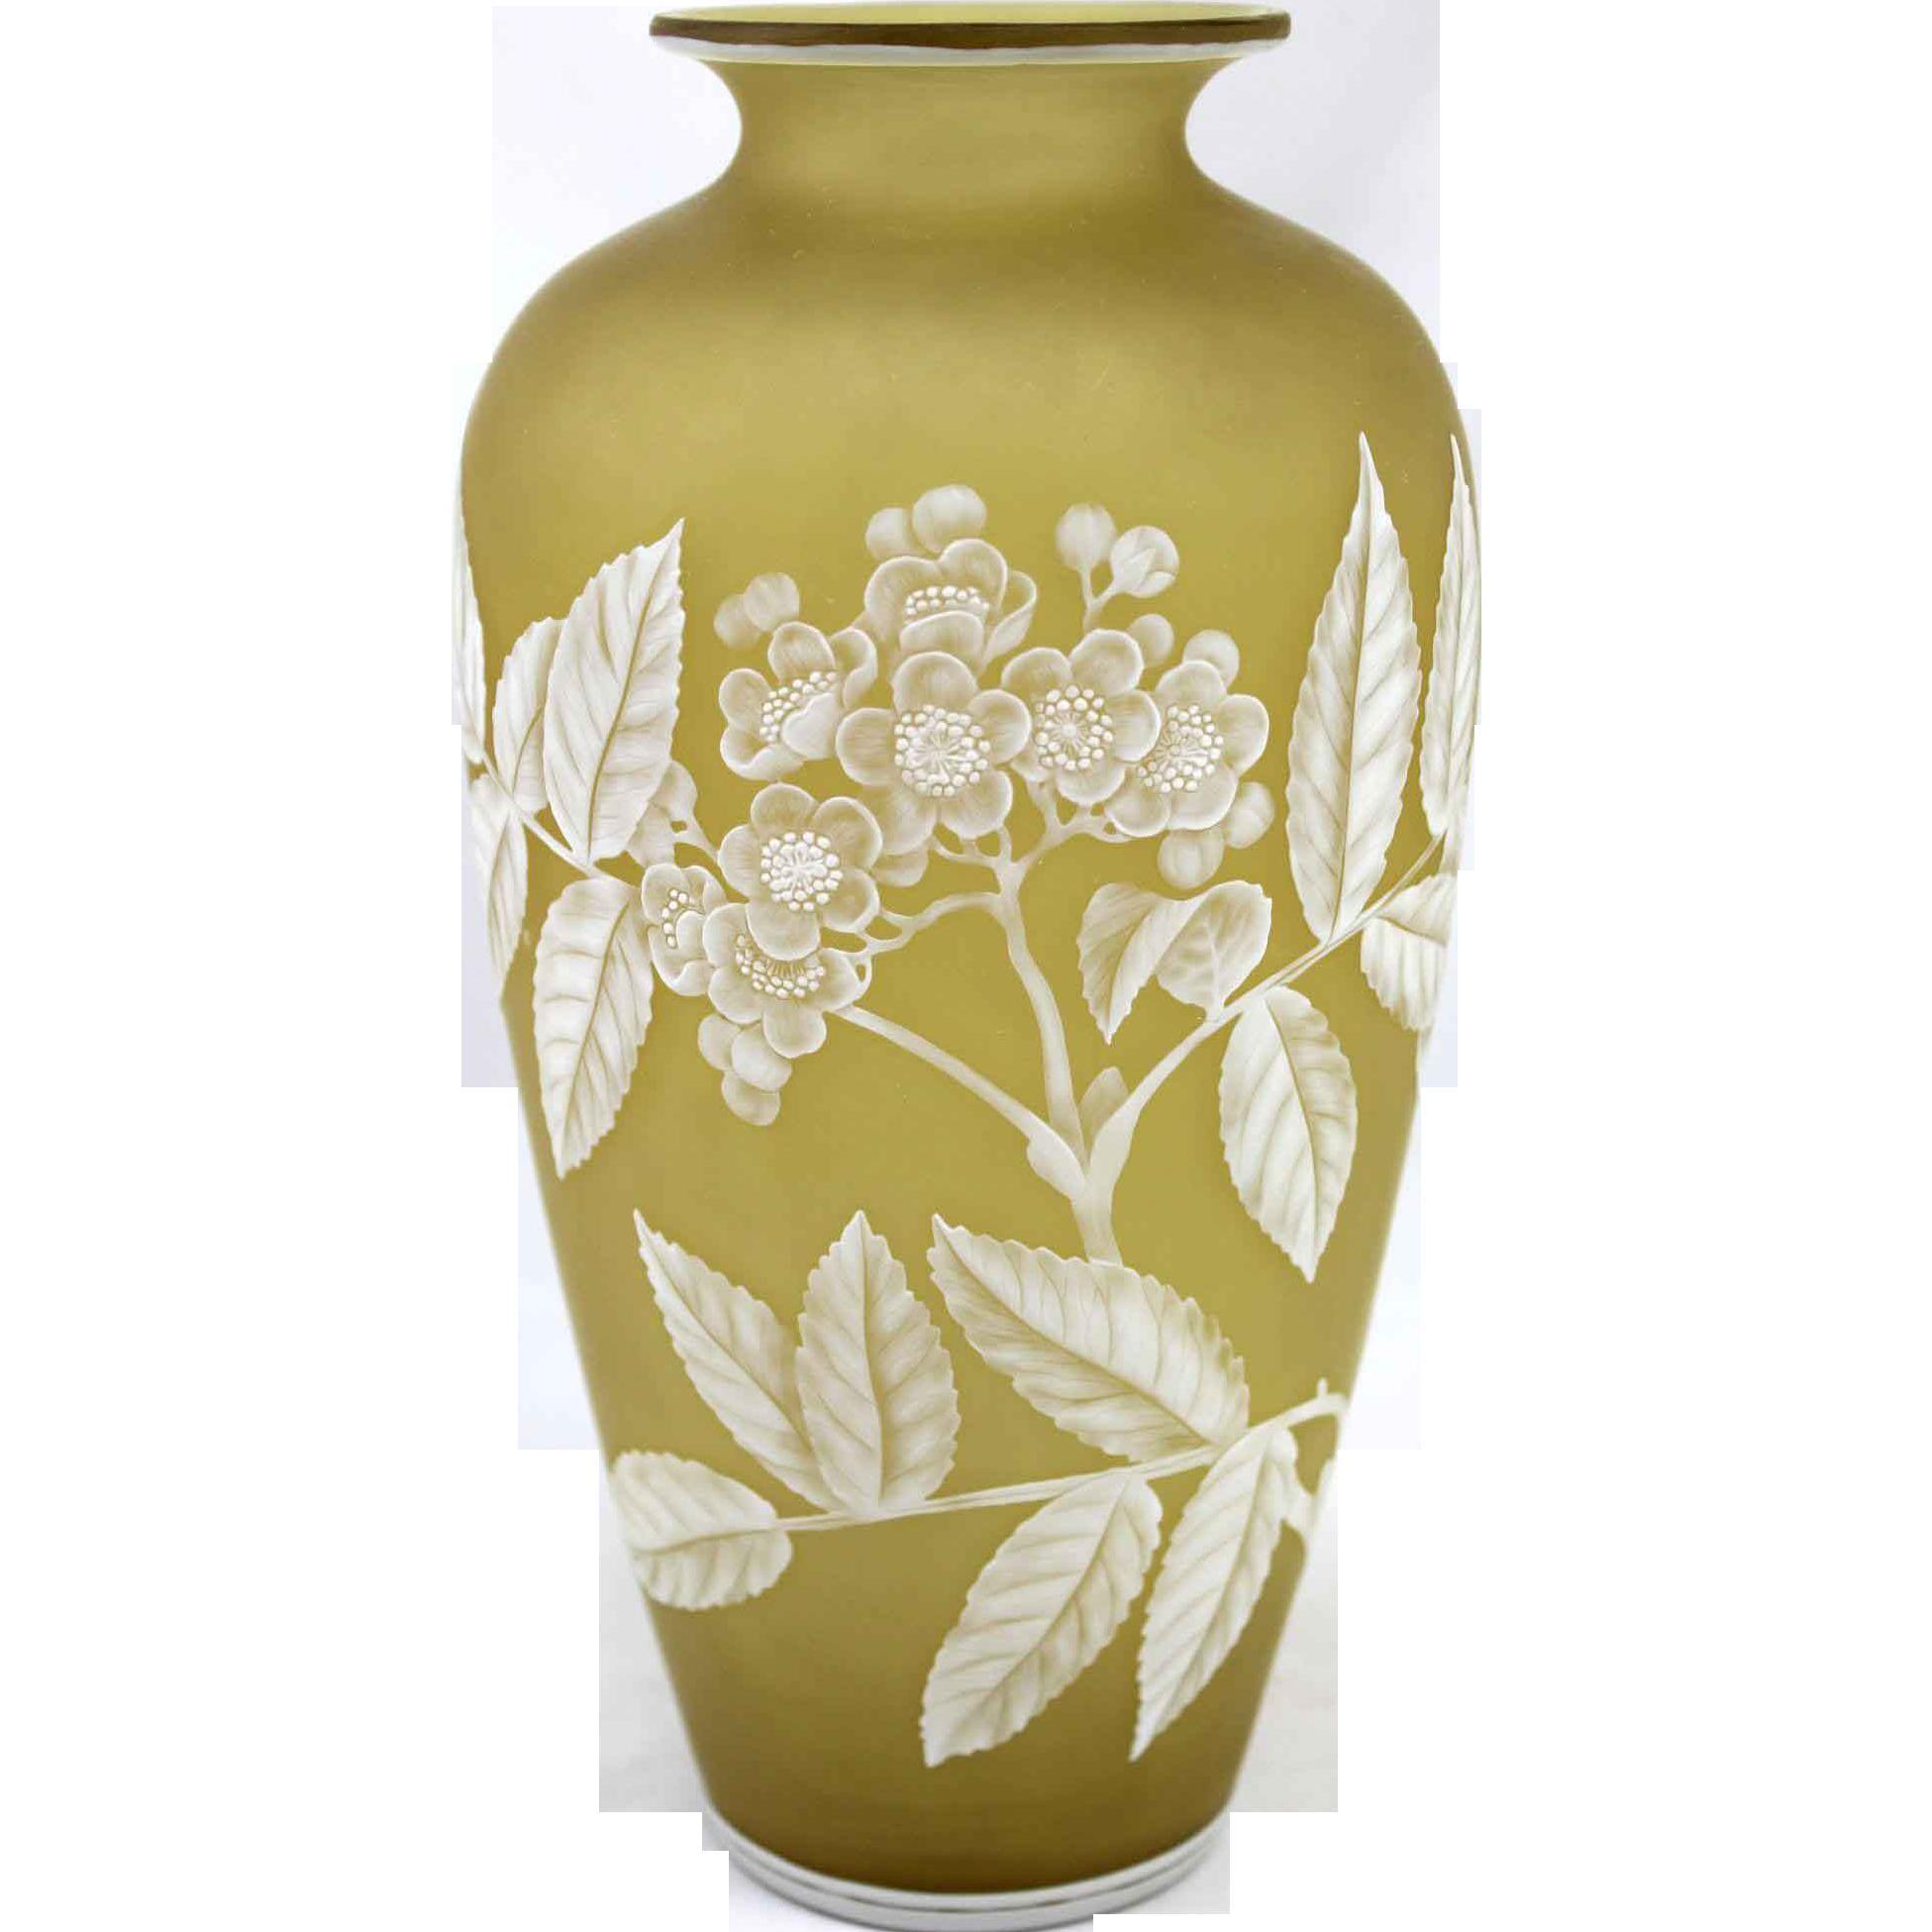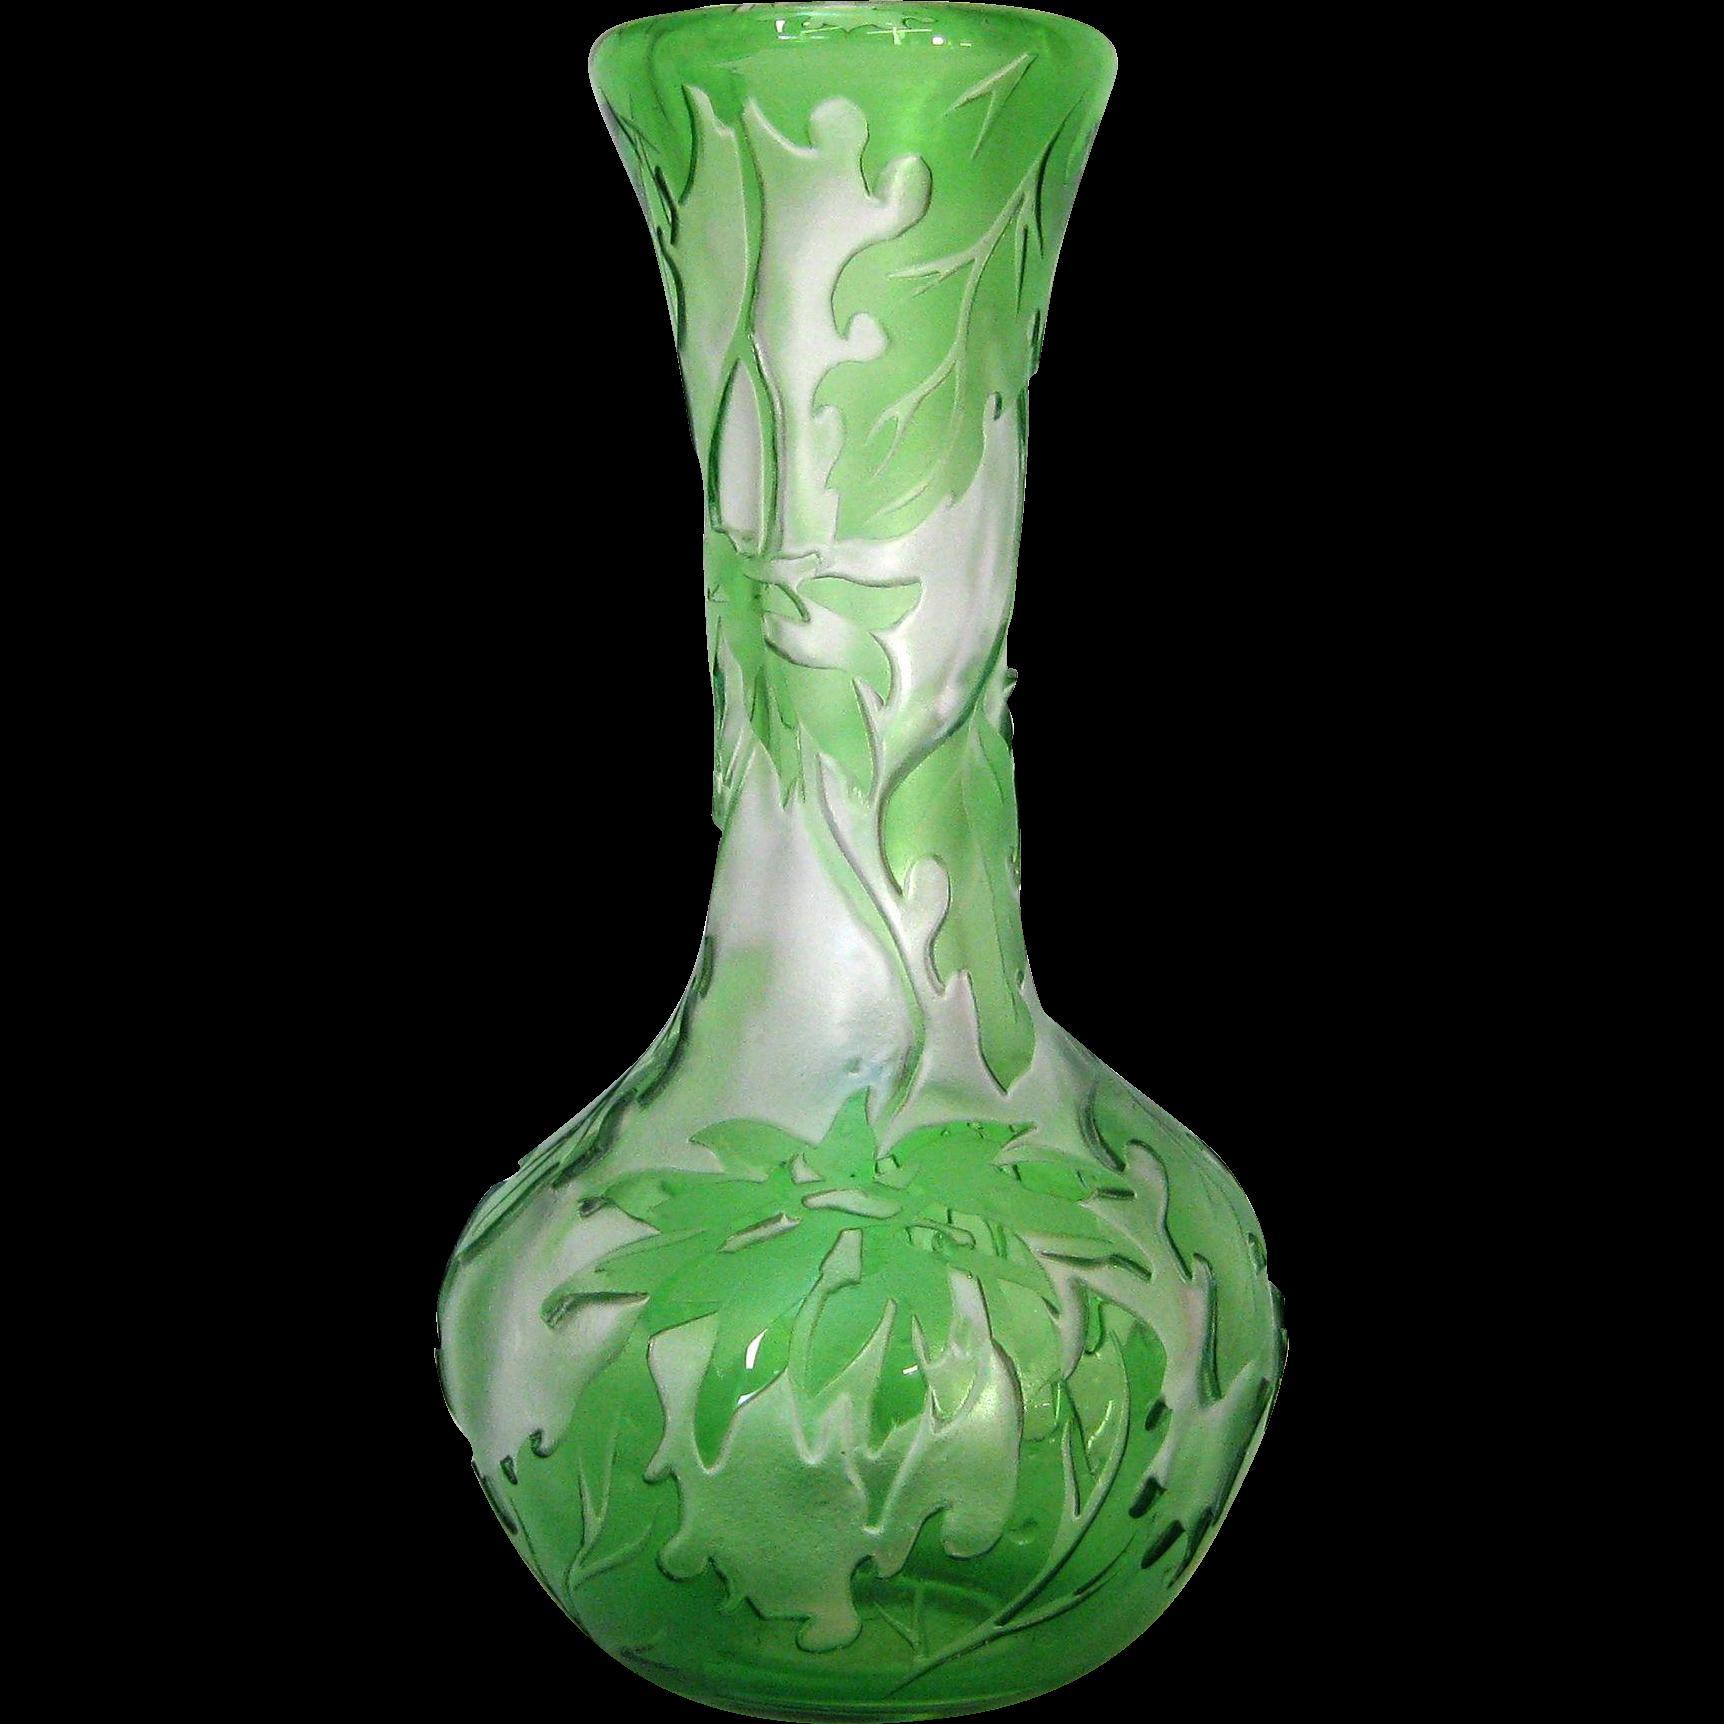The first image is the image on the left, the second image is the image on the right. Considering the images on both sides, is "There is a vase that is predominantly green and a vase that is predominantly yellow." valid? Answer yes or no. Yes. 